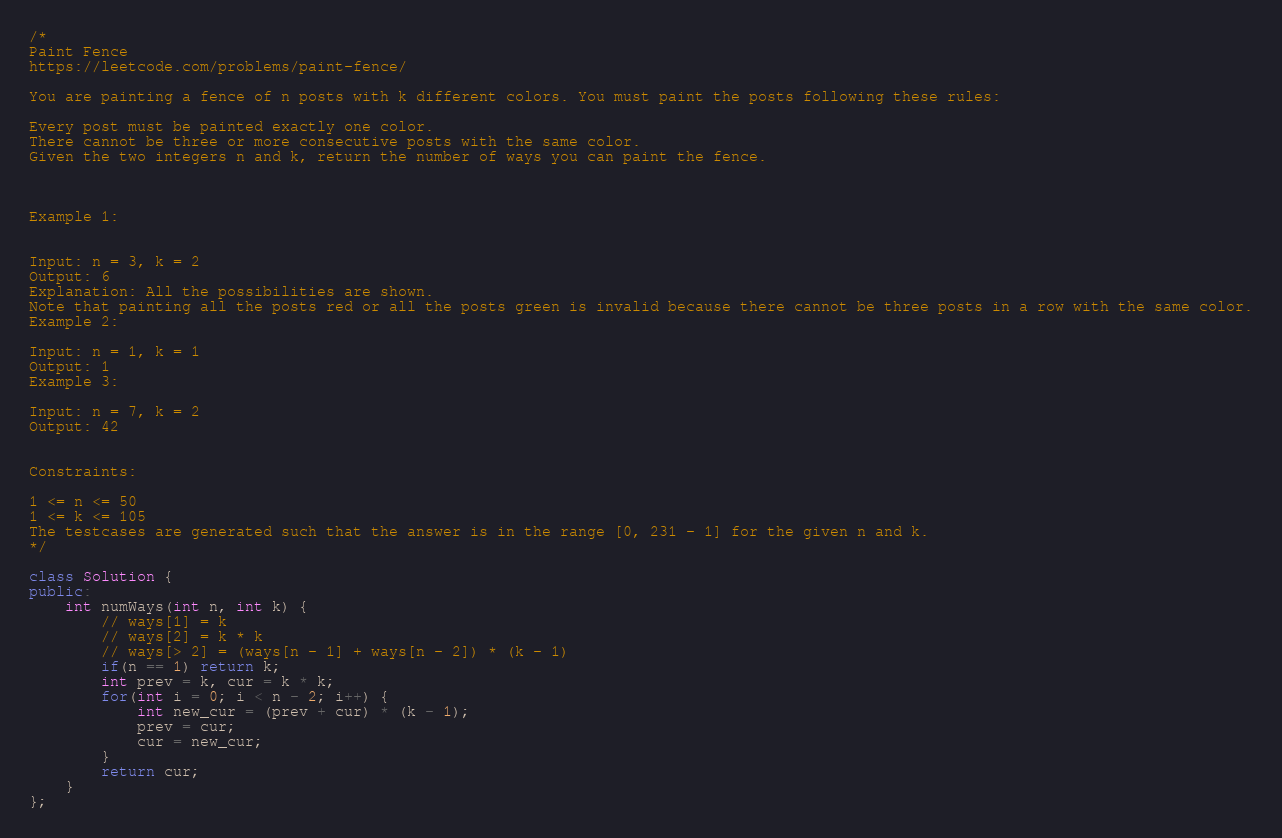<code> <loc_0><loc_0><loc_500><loc_500><_C++_>/*
Paint Fence
https://leetcode.com/problems/paint-fence/

You are painting a fence of n posts with k different colors. You must paint the posts following these rules:

Every post must be painted exactly one color.
There cannot be three or more consecutive posts with the same color.
Given the two integers n and k, return the number of ways you can paint the fence.

 

Example 1:


Input: n = 3, k = 2
Output: 6
Explanation: All the possibilities are shown.
Note that painting all the posts red or all the posts green is invalid because there cannot be three posts in a row with the same color.
Example 2:

Input: n = 1, k = 1
Output: 1
Example 3:

Input: n = 7, k = 2
Output: 42
 

Constraints:

1 <= n <= 50
1 <= k <= 105
The testcases are generated such that the answer is in the range [0, 231 - 1] for the given n and k.
*/

class Solution {
public:
    int numWays(int n, int k) {
    	// ways[1] = k 
    	// ways[2] = k * k
    	// ways[> 2] = (ways[n - 1] + ways[n - 2]) * (k - 1)
        if(n == 1) return k;
        int prev = k, cur = k * k;
        for(int i = 0; i < n - 2; i++) {
            int new_cur = (prev + cur) * (k - 1);
            prev = cur;
            cur = new_cur;
        }
        return cur;
    }
};</code> 